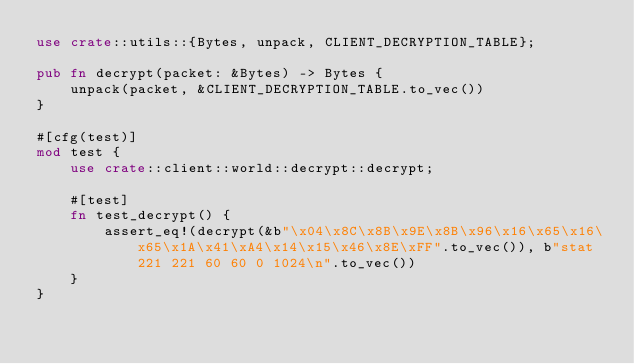Convert code to text. <code><loc_0><loc_0><loc_500><loc_500><_Rust_>use crate::utils::{Bytes, unpack, CLIENT_DECRYPTION_TABLE};

pub fn decrypt(packet: &Bytes) -> Bytes {
    unpack(packet, &CLIENT_DECRYPTION_TABLE.to_vec())
}

#[cfg(test)]
mod test {
    use crate::client::world::decrypt::decrypt;

    #[test]
    fn test_decrypt() {
        assert_eq!(decrypt(&b"\x04\x8C\x8B\x9E\x8B\x96\x16\x65\x16\x65\x1A\x41\xA4\x14\x15\x46\x8E\xFF".to_vec()), b"stat 221 221 60 60 0 1024\n".to_vec())
    }
}</code> 